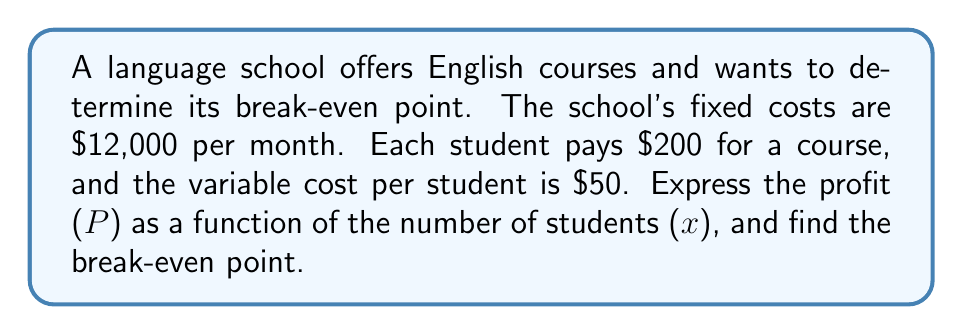Teach me how to tackle this problem. To solve this problem, we'll follow these steps:

1. Express revenue as a function of x:
   Revenue = Price per student × Number of students
   $R(x) = 200x$

2. Express total cost as a function of x:
   Total Cost = Fixed costs + (Variable cost per student × Number of students)
   $C(x) = 12000 + 50x$

3. Express profit as a function of x:
   Profit = Revenue - Total Cost
   $P(x) = R(x) - C(x)$
   $P(x) = 200x - (12000 + 50x)$
   $P(x) = 200x - 12000 - 50x$
   $P(x) = 150x - 12000$

4. To find the break-even point, set profit to zero:
   $P(x) = 0$
   $150x - 12000 = 0$
   $150x = 12000$
   $x = 12000 / 150 = 80$

Therefore, the break-even point occurs when there are 80 students.

To verify:
Revenue at 80 students: $200 × 80 = $16,000
Total cost at 80 students: $12,000 + ($50 × 80) = $16,000

At 80 students, revenue equals total cost, confirming the break-even point.
Answer: The profit function is $P(x) = 150x - 12000$, and the break-even point occurs at 80 students. 